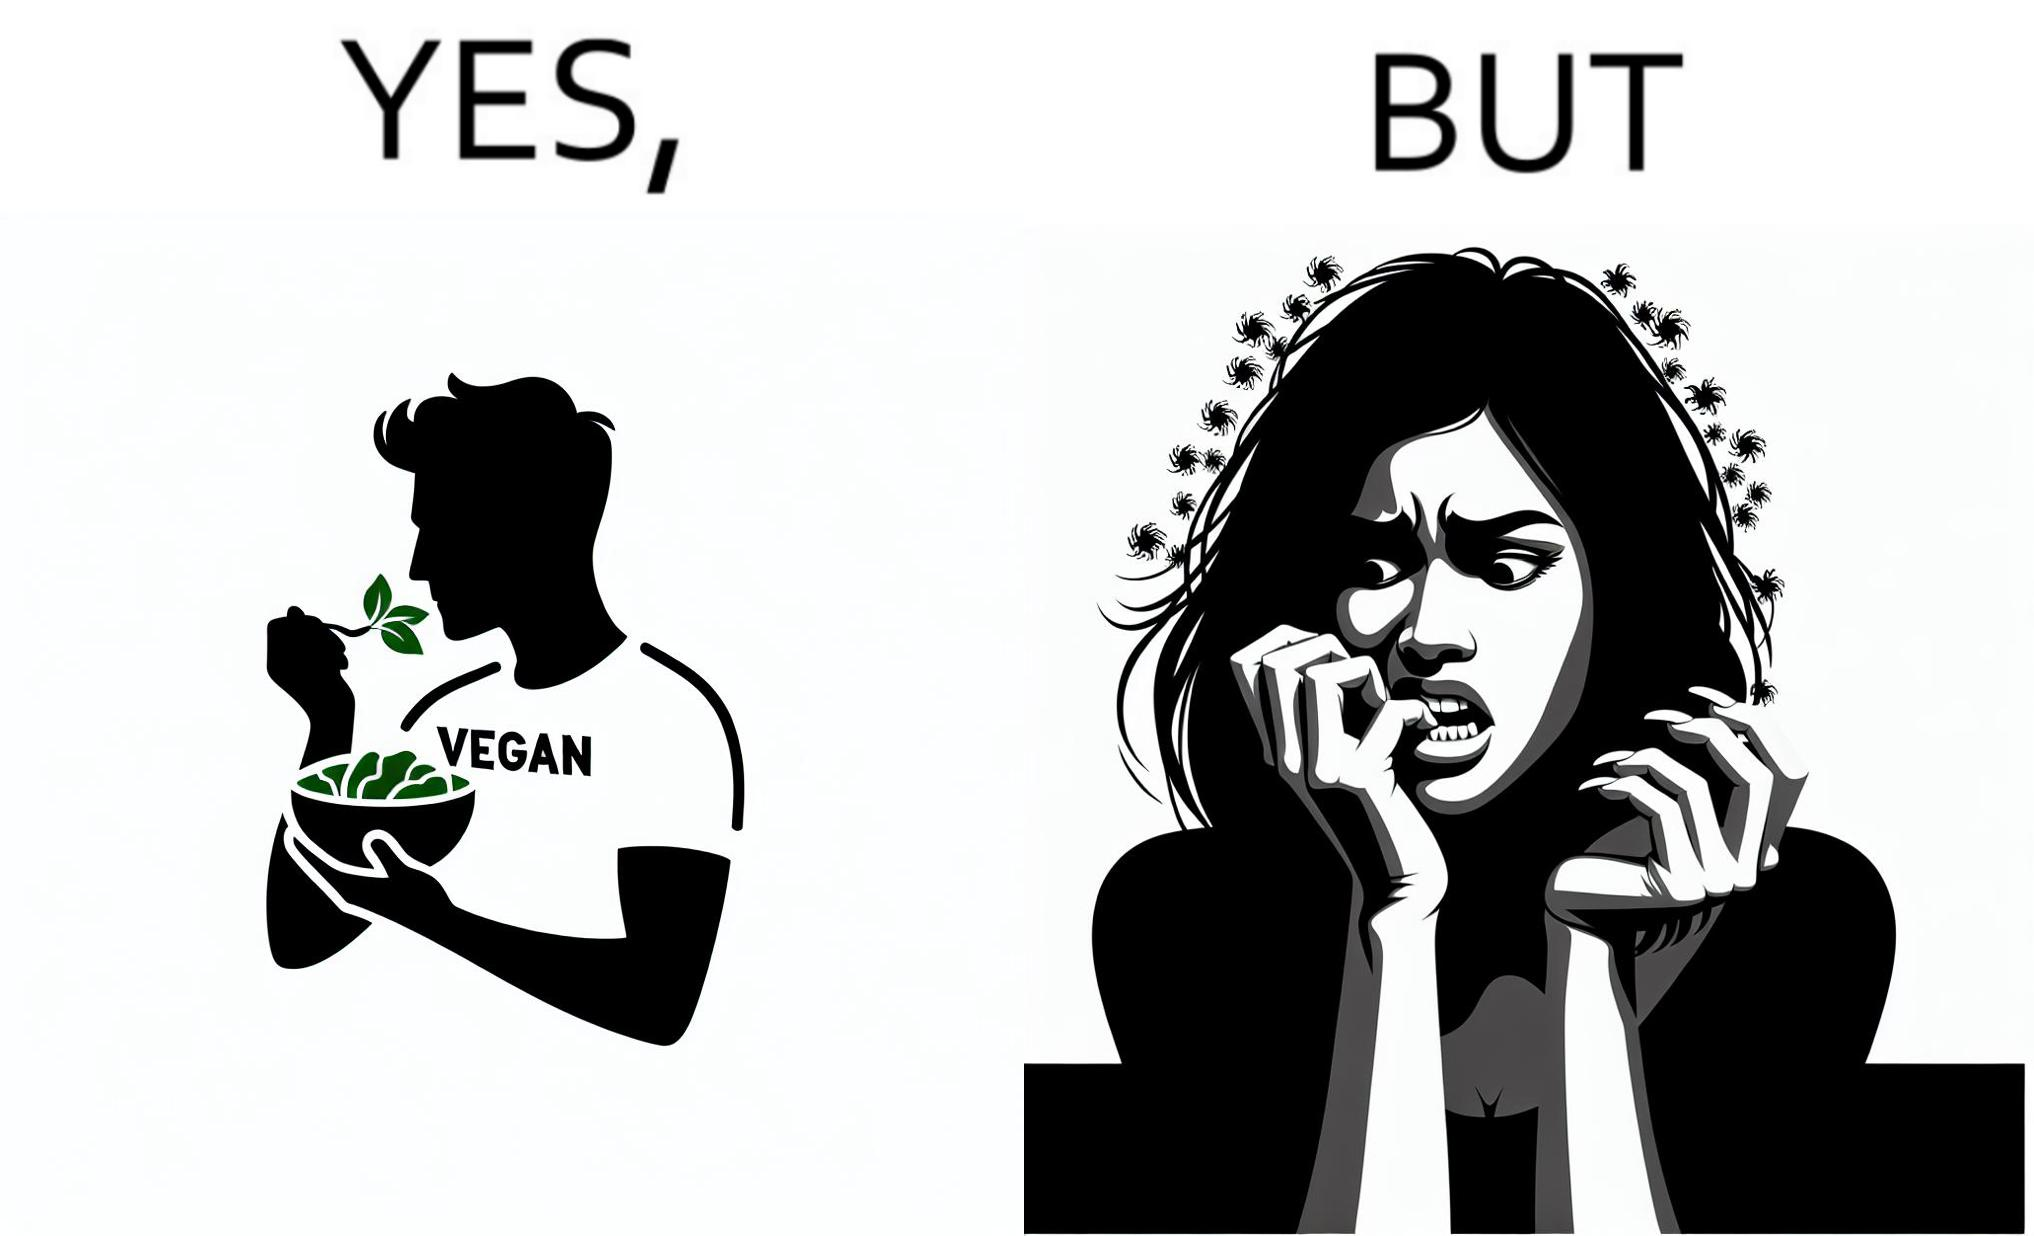Describe the contrast between the left and right parts of this image. In the left part of the image: The image shows a man eating leafy vegetables out of a bowl in his hand. He is also wearing a t-shirt that says vegan. In the right part of the image: The image shows a person biting the skin around the fingernails of thier hand. 